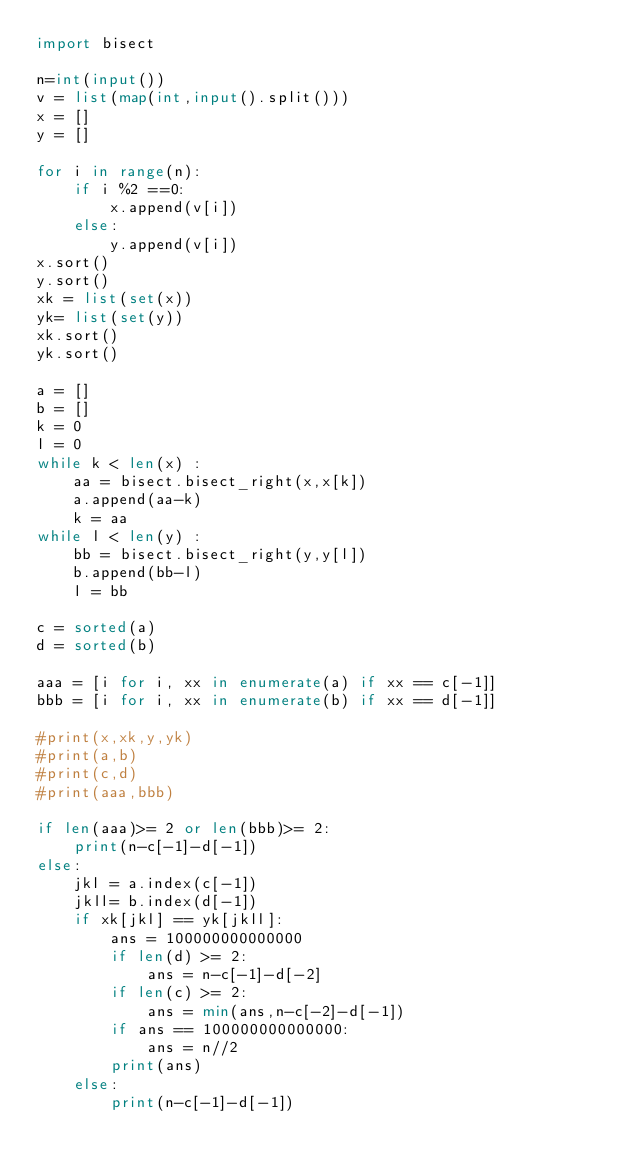Convert code to text. <code><loc_0><loc_0><loc_500><loc_500><_Python_>import bisect

n=int(input())
v = list(map(int,input().split()))
x = []
y = []

for i in range(n):
    if i %2 ==0:
        x.append(v[i])
    else:
        y.append(v[i])
x.sort()
y.sort()
xk = list(set(x))
yk= list(set(y))
xk.sort()
yk.sort()

a = []
b = []
k = 0
l = 0
while k < len(x) :
    aa = bisect.bisect_right(x,x[k])
    a.append(aa-k)
    k = aa
while l < len(y) :
    bb = bisect.bisect_right(y,y[l])
    b.append(bb-l)
    l = bb

c = sorted(a)
d = sorted(b)

aaa = [i for i, xx in enumerate(a) if xx == c[-1]]
bbb = [i for i, xx in enumerate(b) if xx == d[-1]]

#print(x,xk,y,yk)
#print(a,b)
#print(c,d)
#print(aaa,bbb)

if len(aaa)>= 2 or len(bbb)>= 2:
    print(n-c[-1]-d[-1])
else:
    jkl = a.index(c[-1])
    jkll= b.index(d[-1])
    if xk[jkl] == yk[jkll]:
        ans = 100000000000000
        if len(d) >= 2:
            ans = n-c[-1]-d[-2]
        if len(c) >= 2:
            ans = min(ans,n-c[-2]-d[-1])
        if ans == 100000000000000:
            ans = n//2
        print(ans)
    else:
        print(n-c[-1]-d[-1])
        
    </code> 